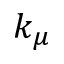<formula> <loc_0><loc_0><loc_500><loc_500>k _ { \mu }</formula> 